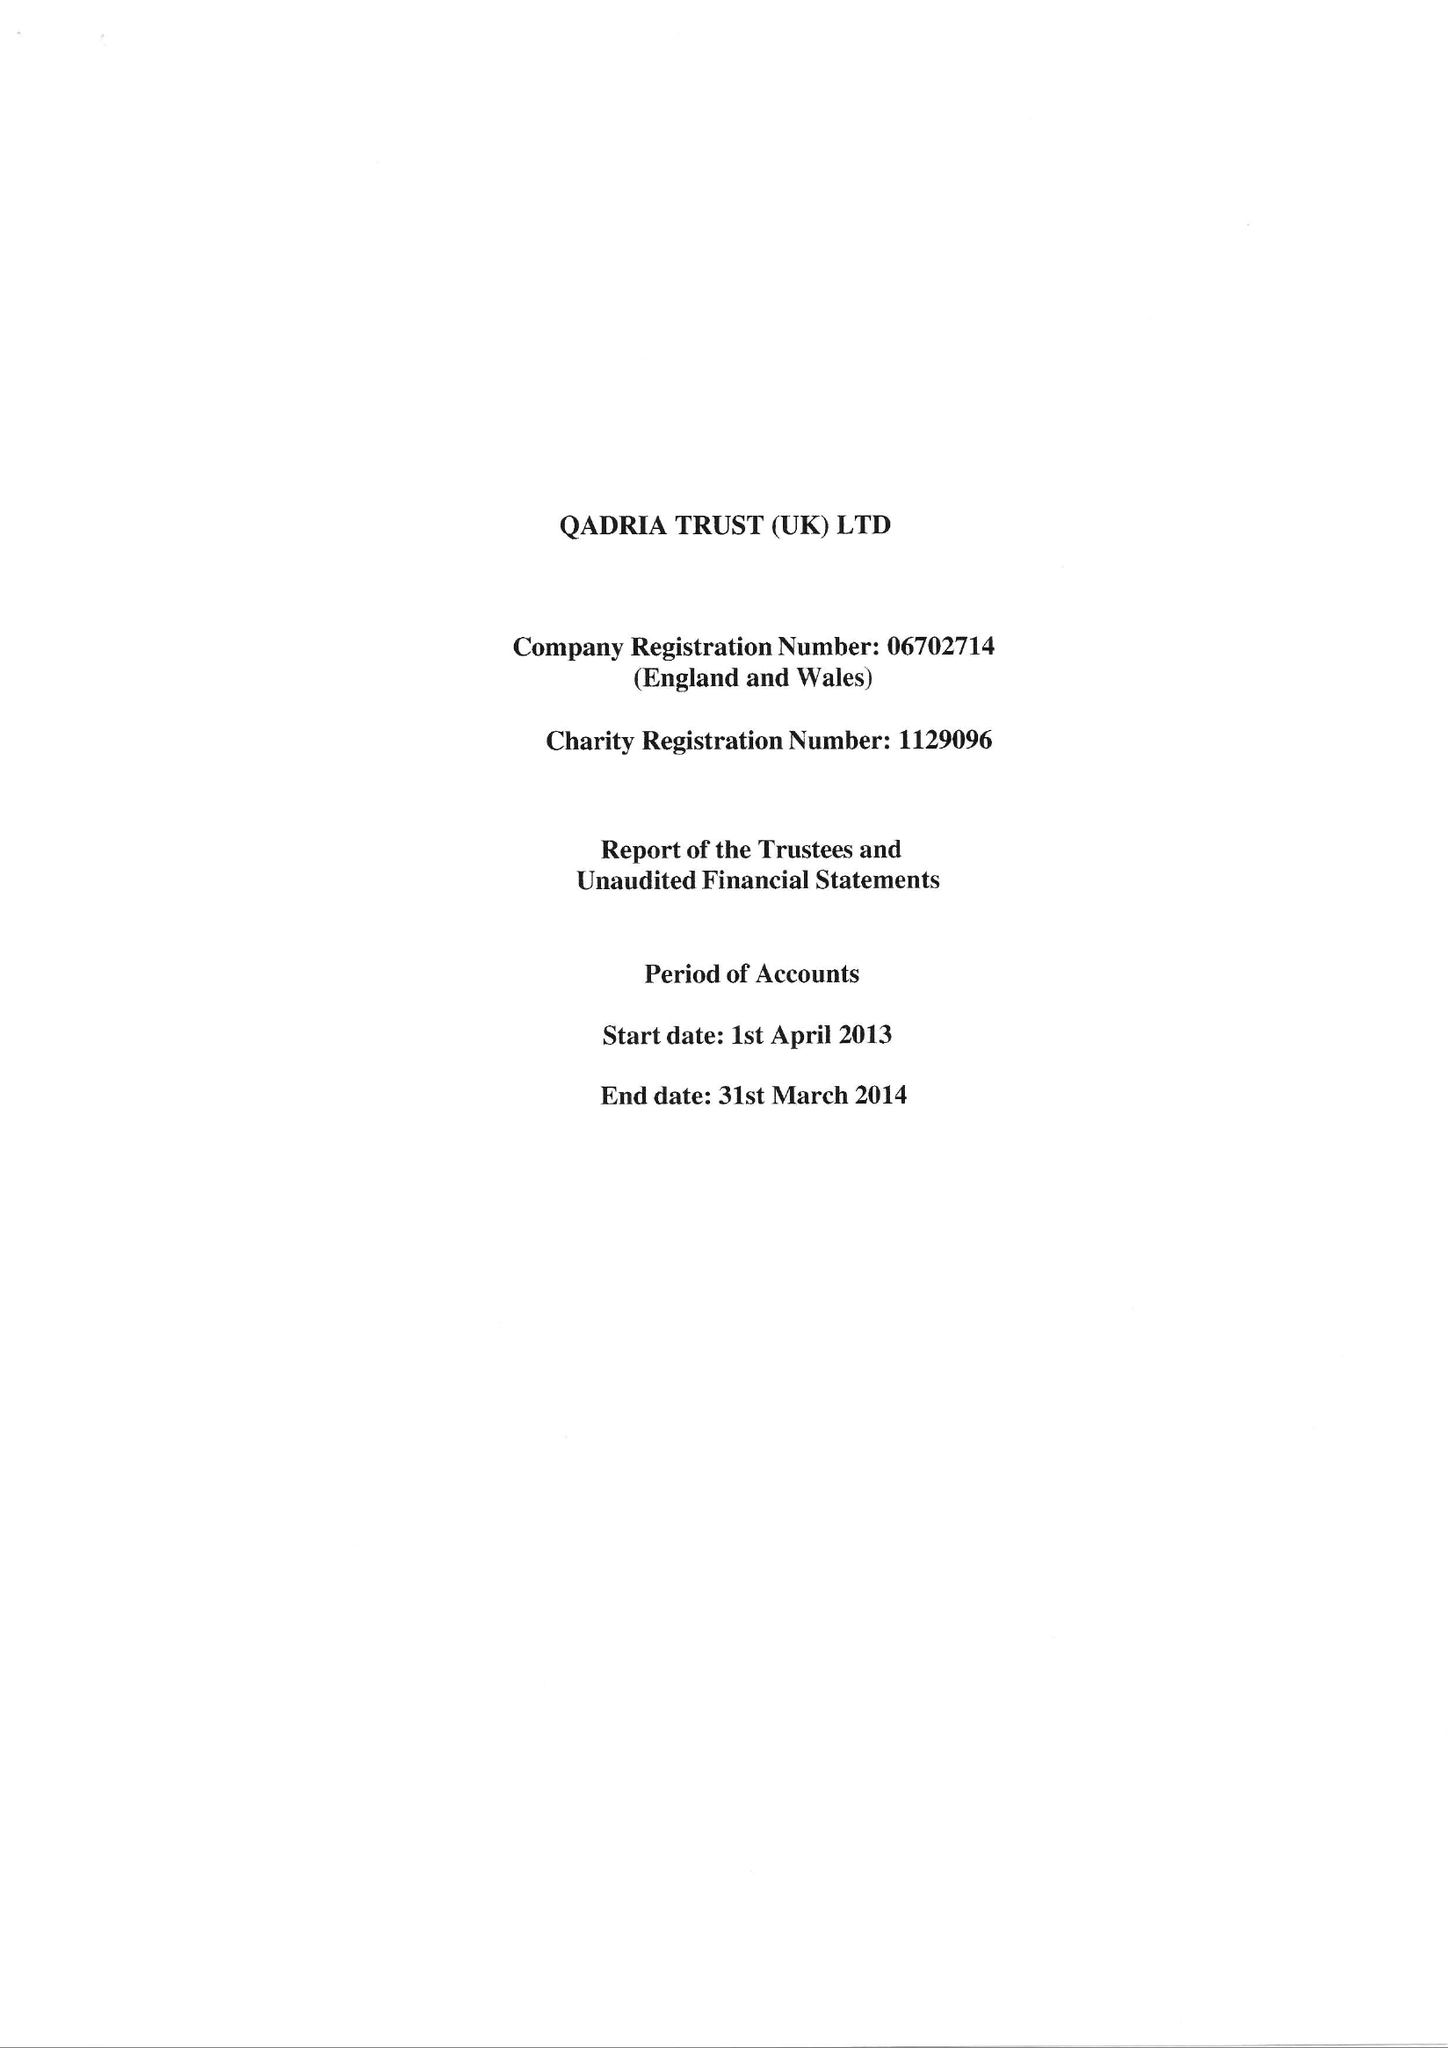What is the value for the charity_number?
Answer the question using a single word or phrase. 1129096 